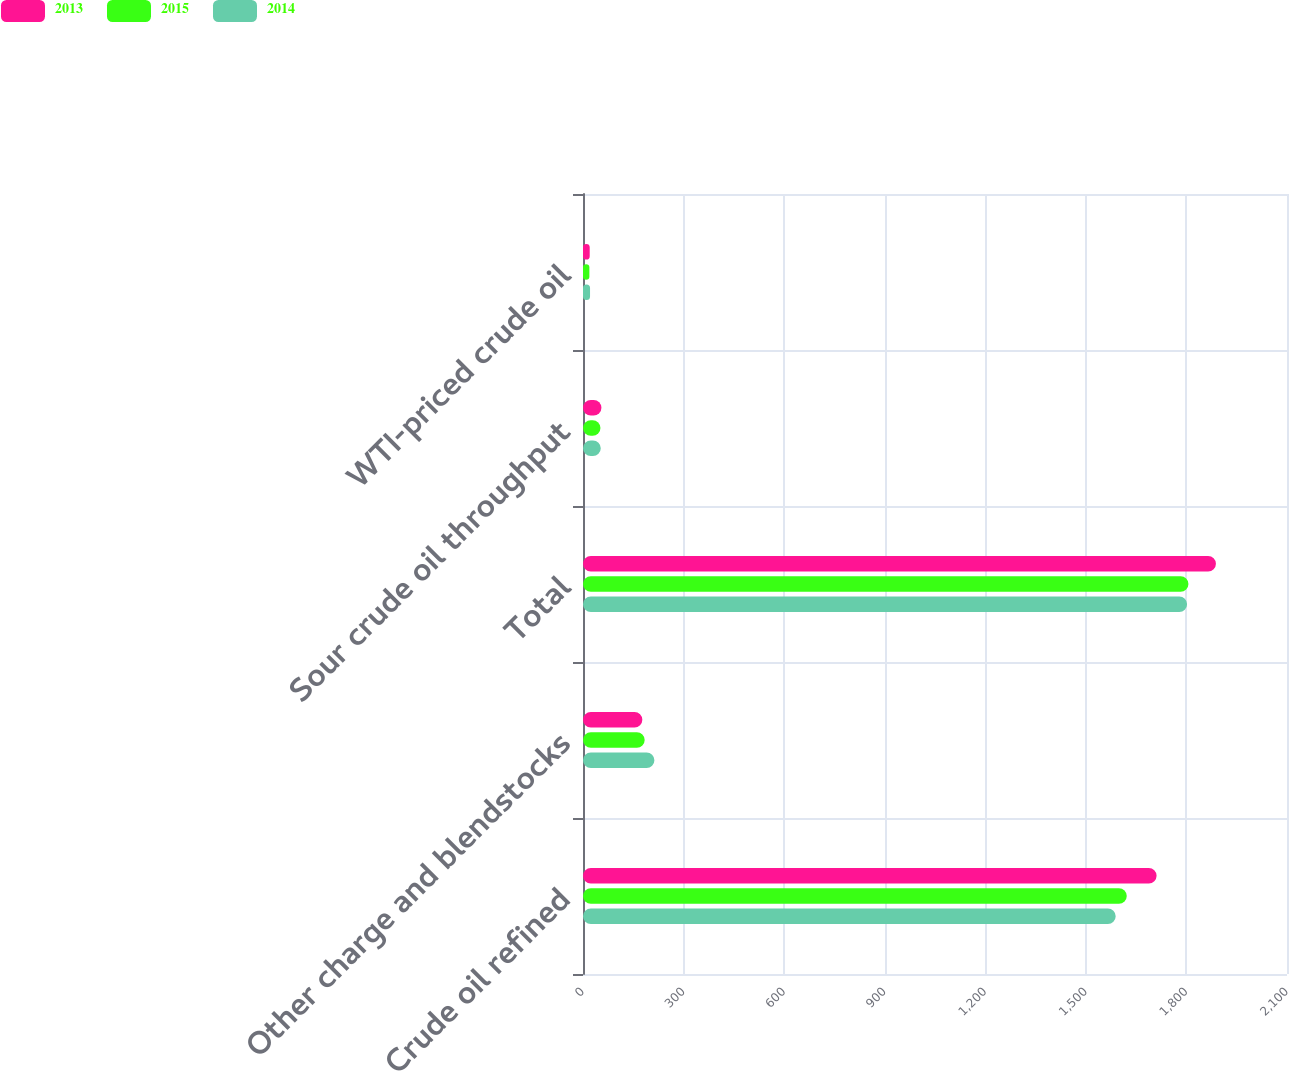Convert chart to OTSL. <chart><loc_0><loc_0><loc_500><loc_500><stacked_bar_chart><ecel><fcel>Crude oil refined<fcel>Other charge and blendstocks<fcel>Total<fcel>Sour crude oil throughput<fcel>WTI-priced crude oil<nl><fcel>2013<fcel>1711<fcel>177<fcel>1888<fcel>55<fcel>20<nl><fcel>2015<fcel>1622<fcel>184<fcel>1806<fcel>52<fcel>19<nl><fcel>2014<fcel>1589<fcel>213<fcel>1802<fcel>53<fcel>21<nl></chart> 